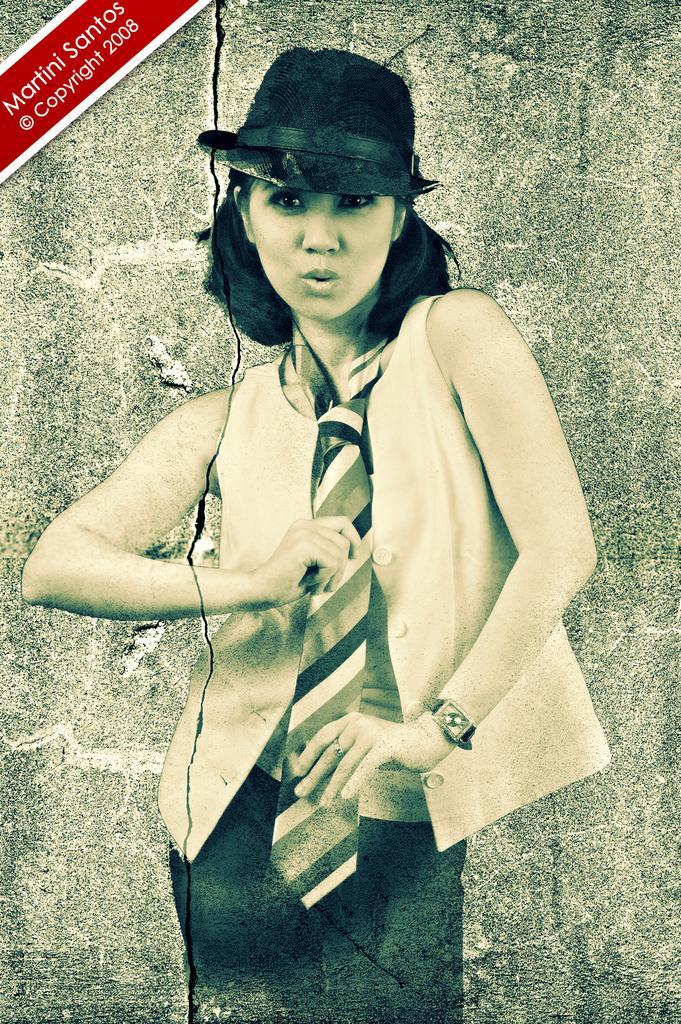In one or two sentences, can you explain what this image depicts? In this picture we can see a woman in the front, in the background there is a wall, we can see some text at the left top of the picture. 